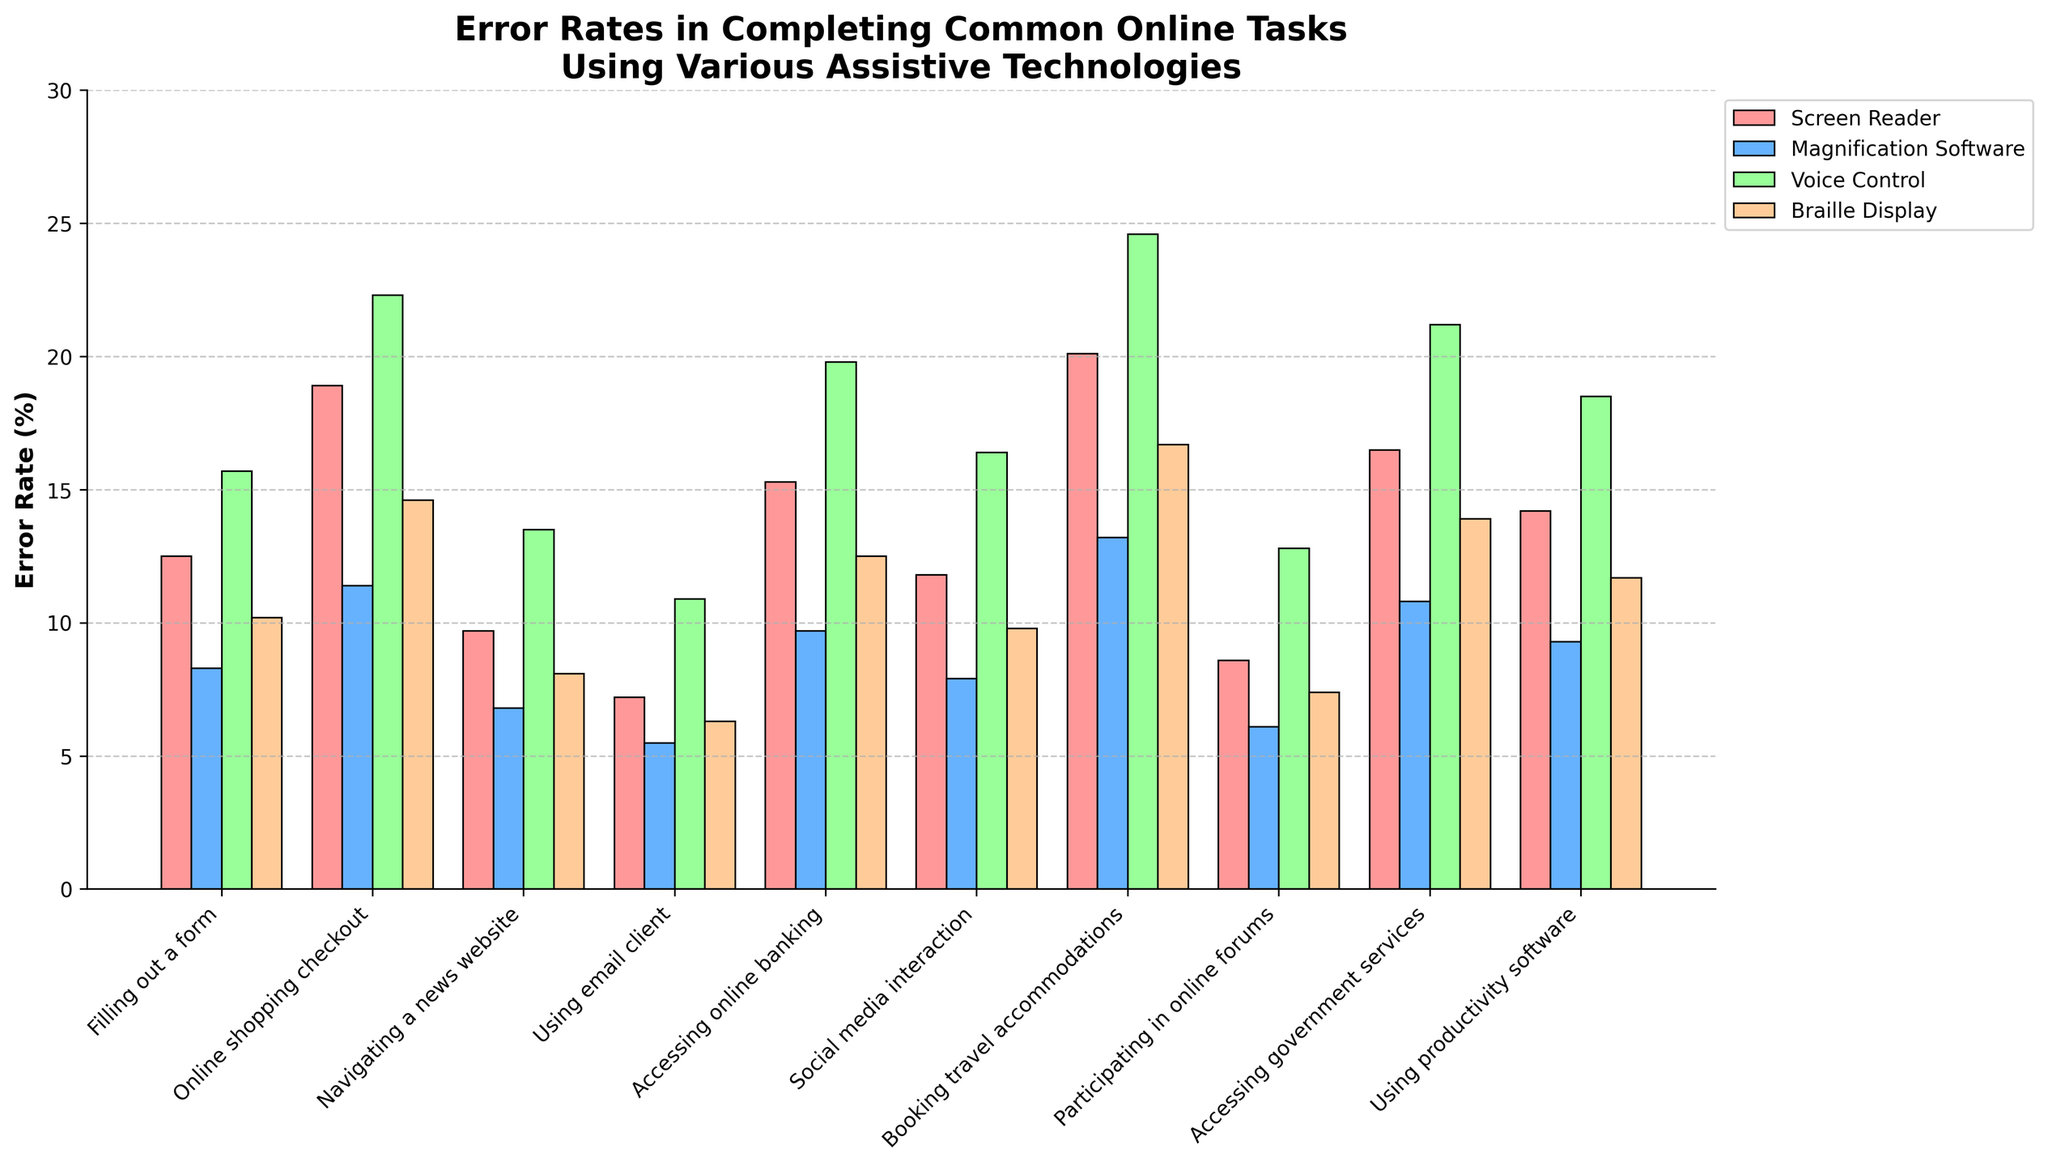What task has the highest error rate using Voice Control? Look at the bar heights for Voice Control across all tasks. The tallest bar represents the highest error rate, which is for "Booking travel accommodations" with an error rate of 24.6%.
Answer: Booking travel accommodations Which assistive technology has the lowest error rate for using an email client? Compare the error rates for all four assistive technologies for the task "Using email client" using the bar heights. The lowest bar corresponds to Magnification Software with an error rate of 5.5%.
Answer: Magnification Software What is the average error rate for accessing government services across all assistive technologies? Sum the error rates for "Accessing government services" for each technology: (16.5 + 10.8 + 21.2 + 13.9). The total is 62.4. Divide this by the number of technologies, 4.
Answer: 15.6% Which assistive technology shows the most consistency in error rates across tasks? By observing the variation in bar heights for each assistive technology across tasks, Braille Display appears to have the most consistent performance, with less drastic changes in error rates compared to others.
Answer: Braille Display Compare the error rates for online shopping checkout between Screen Reader and Magnification Software. Which has a higher rate, and by how much? Look at the bars for "Online shopping checkout" for both Screen Reader (18.9) and Magnification Software (11.4). Screen Reader has a higher error rate. The difference is 18.9 - 11.4 = 7.5.
Answer: Screen Reader by 7.5% For which tasks does Magnification Software outperform all other assistive technologies in terms of the lowest error rate? Check for the shortest bars under Magnification Software across all tasks: "Filling out a form", "Online shopping checkout", "Navigating a news website", "Using email client", "Participating in online forums". Magnification Software has the lowest error rate for these tasks.
Answer: Filling out a form, Online shopping checkout, Navigating a news website, Using email client, Participating in online forums What is the total error rate when summing all technologies for the task “Social media interaction”? Sum the error rates for "Social media interaction" across all technologies: (11.8 + 7.9 + 16.4 + 9.8) = 45.9.
Answer: 45.9% Which task has the smallest difference in error rates between Screen Reader and Braille Display? Subtract the error rates for Screen Reader and Braille Display across all tasks, then find the smallest difference: “Navigating a news website" (9.7 - 8.1 = 1.6) is the smallest.
Answer: Navigating a news website For which task is the error rate for Voice Control more than double the rate for Magnification Software? Check for any task where the Voice Control error rate is more than twice that of Magnification Software. For "Booking travel accommodations" (Voice Control: 24.6, Magnification Software: 13.2), 24.6 > 2 * 13.2 = 26.4, this does not meet the criteria. Now check “Using email client” (Voice Control 10.9, Magnification Software 5.5), 10.9 > 2 * 5.5= 11. (No task meets this condition.)
Answer: None 